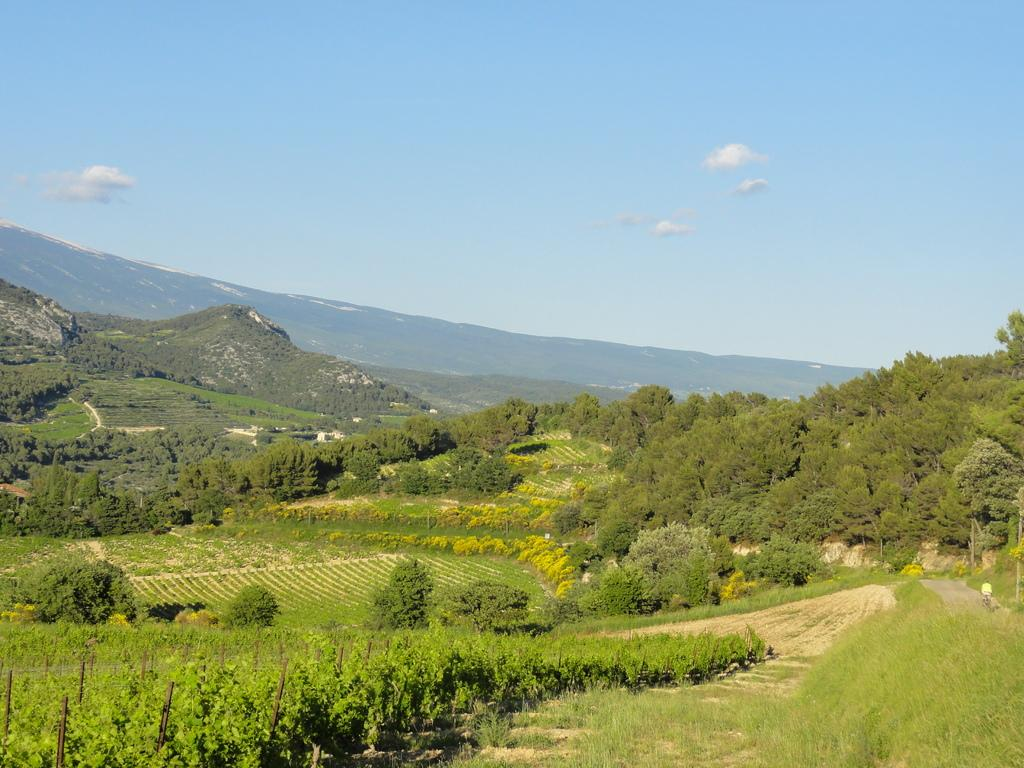What type of vegetation can be seen in the image? There are trees, plants, and grass visible in the image. What natural features are present in the image? There are hills in the image. What is visible in the background of the image? There is sky visible in the image, with clouds present. How does the stem of the tree support the walk of the animals in the image? There are no animals present in the image, and trees do not have stems; they have trunks. 